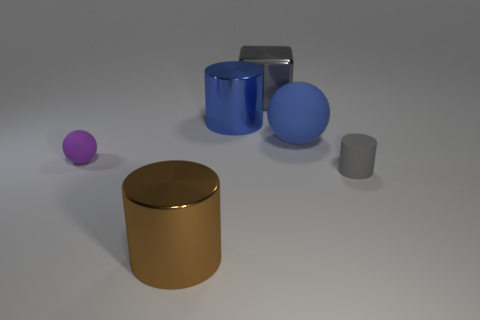There is a small thing that is right of the big metallic thing in front of the tiny rubber cylinder; what shape is it?
Your response must be concise. Cylinder. Are there fewer large gray shiny cubes than big metallic cylinders?
Your answer should be compact. Yes. Is the big brown thing made of the same material as the small cylinder?
Provide a succinct answer. No. What is the color of the cylinder that is left of the gray matte cylinder and behind the large brown cylinder?
Offer a terse response. Blue. Is there a yellow metal object that has the same size as the blue metallic thing?
Your answer should be compact. No. What size is the metallic cylinder behind the small matte thing that is to the left of the big gray object?
Keep it short and to the point. Large. Are there fewer small things on the right side of the tiny gray matte cylinder than small gray metallic objects?
Offer a terse response. No. Is the color of the rubber cylinder the same as the big rubber object?
Ensure brevity in your answer.  No. What is the size of the gray rubber object?
Offer a terse response. Small. How many metal blocks are the same color as the tiny rubber cylinder?
Your answer should be very brief. 1. 